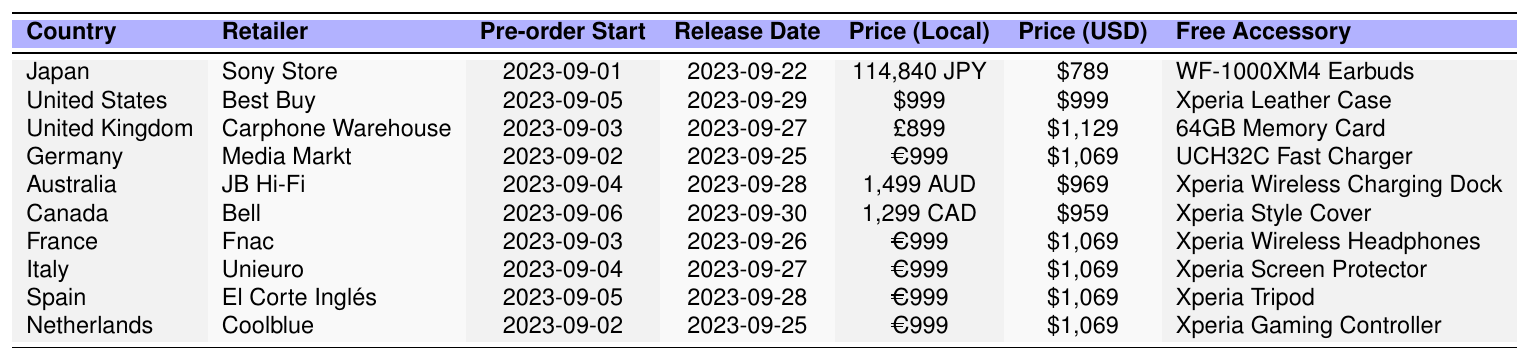What is the price of the Sony Xperia 5 IV in Japan? The table shows that in Japan, the price of the Sony Xperia 5 IV is listed as 114,840 JPY.
Answer: 114,840 JPY When does the pre-order start in the United Kingdom? According to the table, the pre-order for the Sony Xperia 5 IV in the United Kingdom starts on 2023-09-03.
Answer: 2023-09-03 Which retailer is offering the device in Canada? The retailer in Canada listed in the table is Bell.
Answer: Bell What is the local price of the Sony Xperia 5 IV in Australia? In Australia, the local price is 1,499 AUD as stated in the table.
Answer: 1,499 AUD Is the free accessory in the United States a case? The table indicates that the free accessory offered in the United States is an Xperia Leather Case, so the answer is yes.
Answer: Yes How many countries are listed in the table for pre-ordering the Sony Xperia 5 IV? The table provides information for 10 countries, which can be counted directly from the rows in the data provided.
Answer: 10 What is the release date for the Sony Xperia 5 IV in Germany? The release date for Germany listed in the table is 2023-09-25.
Answer: 2023-09-25 Which country has the highest price in USD for the Sony Xperia 5 IV? Scanning through the table, the highest price in USD is $1,129 in the United Kingdom.
Answer: United Kingdom If we average the prices in USD for all listed countries, what is the result? To find the average, add all the USD prices: 789 + 999 + 1129 + 1069 + 969 + 959 + 1069 + 1069 + 1069 + 1069 = 10,500, and there are 10 countries, so the average is 10,500 / 10 = $1,050.
Answer: $1,050 Is the pre-order start date in Spain the same as in the Netherlands? The table shows that Spain's pre-order starts on 2023-09-05 and Netherlands on 2023-09-02, so they are not the same.
Answer: No What accessories are provided for the pricing in France and Italy? The table states France offers Xperia Wireless Headphones while Italy provides an Xperia Screen Protector for pre-orders.
Answer: Wireless Headphones and Screen Protector 